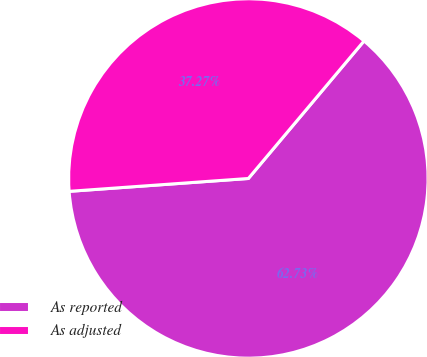Convert chart. <chart><loc_0><loc_0><loc_500><loc_500><pie_chart><fcel>As reported<fcel>As adjusted<nl><fcel>62.73%<fcel>37.27%<nl></chart> 